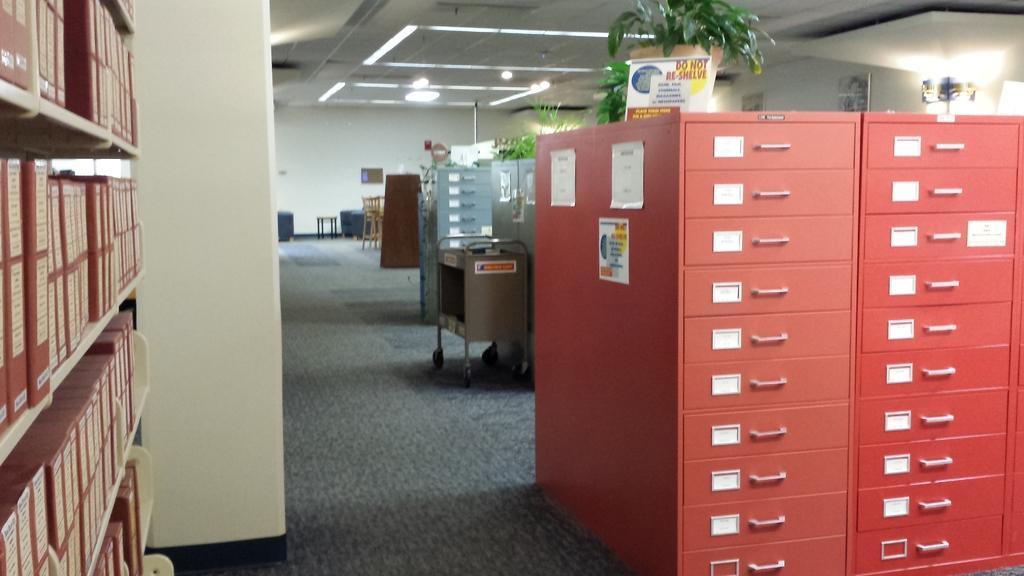Can you describe this image briefly? In this image in the front on the right side there is a cupboard which is red in colour and on the top of the cup board there is a plant in the pot and there is a banner with some text written on it. On the left side there is a shelf with the books in it and in the background there are cupboards, there are chairs and there are blue colour objects. On the top there are lights and there are plants. 